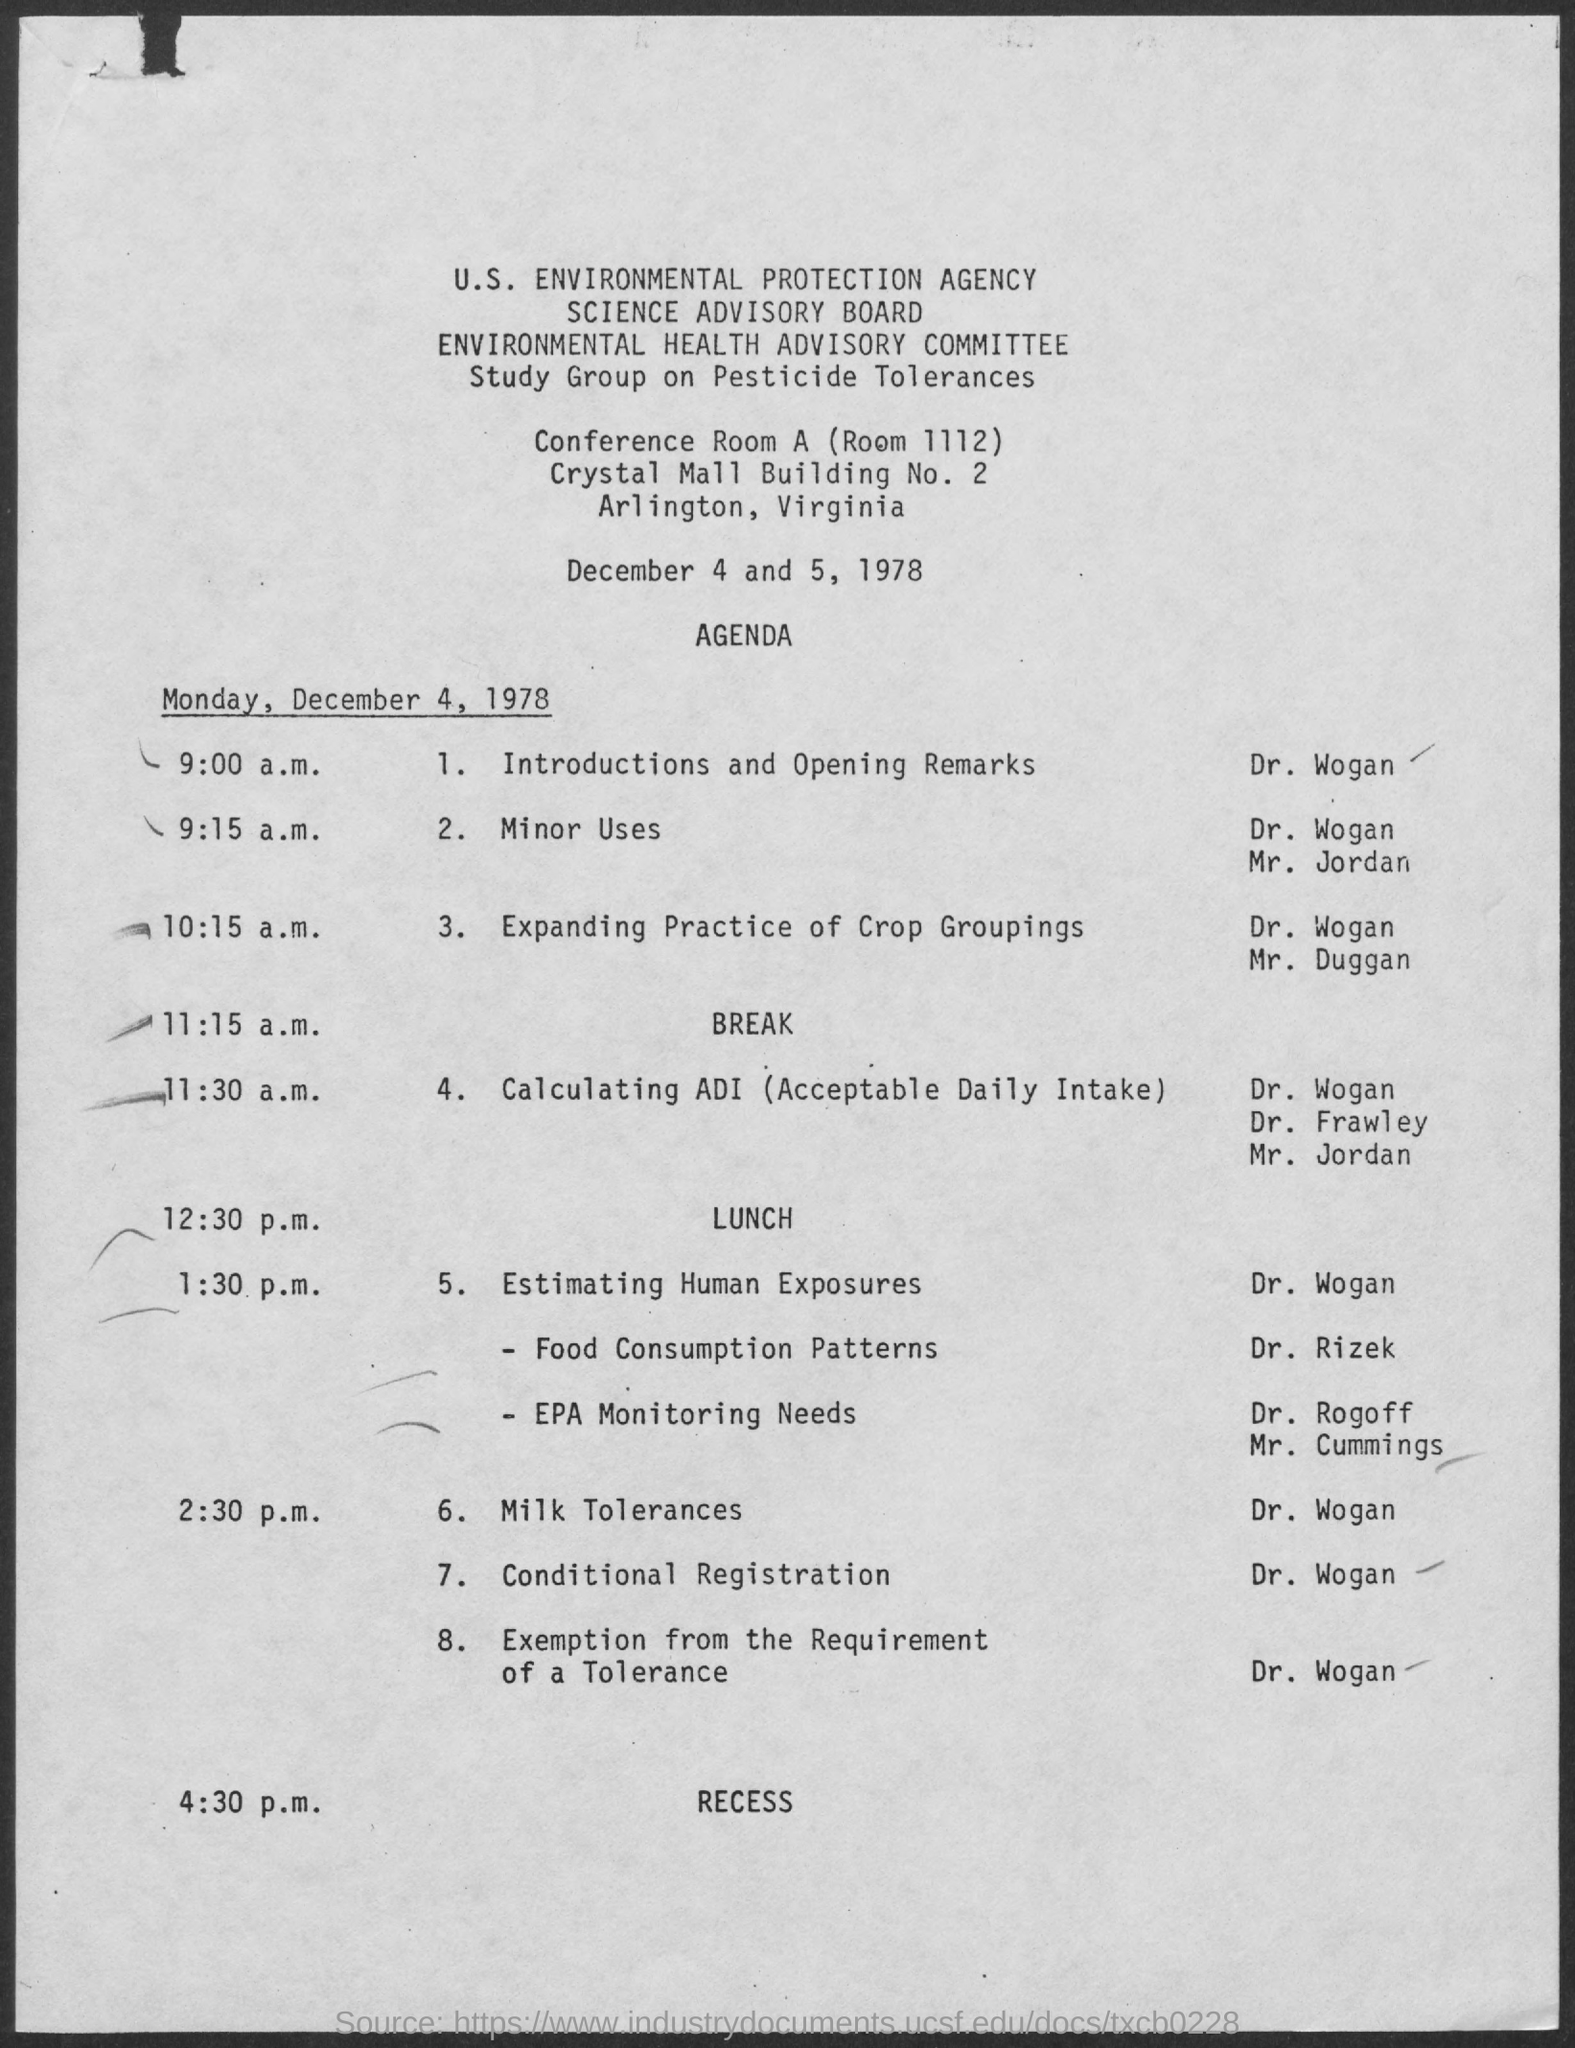Mention a couple of crucial points in this snapshot. The full form of ADI is Acceptable Daily Intake. After lunch, the first topic of discussion was estimating human exposures. 